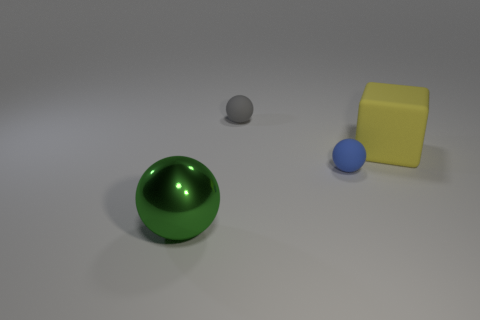Add 3 large cyan metallic balls. How many objects exist? 7 Subtract all spheres. How many objects are left? 1 Subtract all gray balls. Subtract all tiny matte spheres. How many objects are left? 1 Add 2 gray rubber things. How many gray rubber things are left? 3 Add 2 big matte blocks. How many big matte blocks exist? 3 Subtract 0 red cylinders. How many objects are left? 4 